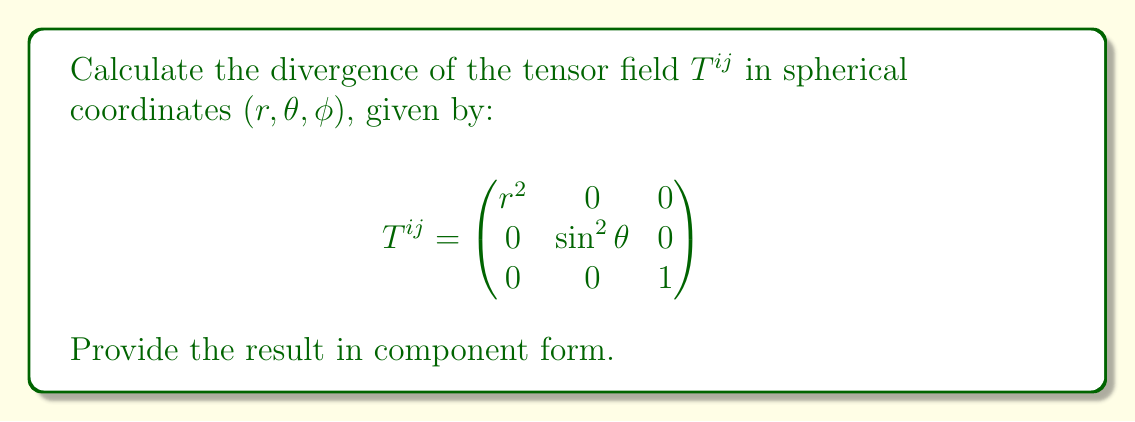Provide a solution to this math problem. To calculate the divergence of a tensor field in curvilinear coordinates, we use the formula:

$$\nabla \cdot T^{ij} = \frac{1}{\sqrt{g}} \frac{\partial}{\partial x^i} (\sqrt{g} T^{ij})$$

Where $g$ is the determinant of the metric tensor.

Step 1: Determine the metric tensor and its determinant for spherical coordinates:
$$g_{ij} = \begin{pmatrix}
1 & 0 & 0 \\
0 & r^2 & 0 \\
0 & 0 & r^2\sin^2\theta
\end{pmatrix}$$
$$\sqrt{g} = r^2\sin\theta$$

Step 2: Calculate the divergence for each component:

For $j = 1$ (r-component):
$$\frac{1}{r^2\sin\theta} \frac{\partial}{\partial r} (r^2\sin\theta \cdot r^2) = \frac{1}{r^2\sin\theta} \frac{\partial}{\partial r} (r^4\sin\theta) = 4r$$

For $j = 2$ ($\theta$-component):
$$\frac{1}{r^2\sin\theta} \frac{\partial}{\partial \theta} (r^2\sin\theta \cdot \sin^2\theta) = \frac{1}{r^2\sin\theta} \frac{\partial}{\partial \theta} (r^2\sin^3\theta) = \frac{3\cos\theta}{\sin\theta}$$

For $j = 3$ ($\phi$-component):
$$\frac{1}{r^2\sin\theta} \frac{\partial}{\partial \phi} (r^2\sin\theta \cdot 1) = 0$$

Step 3: Combine the results into component form.
Answer: $\nabla \cdot T^{ij} = (4r, \frac{3\cos\theta}{\sin\theta}, 0)$ 